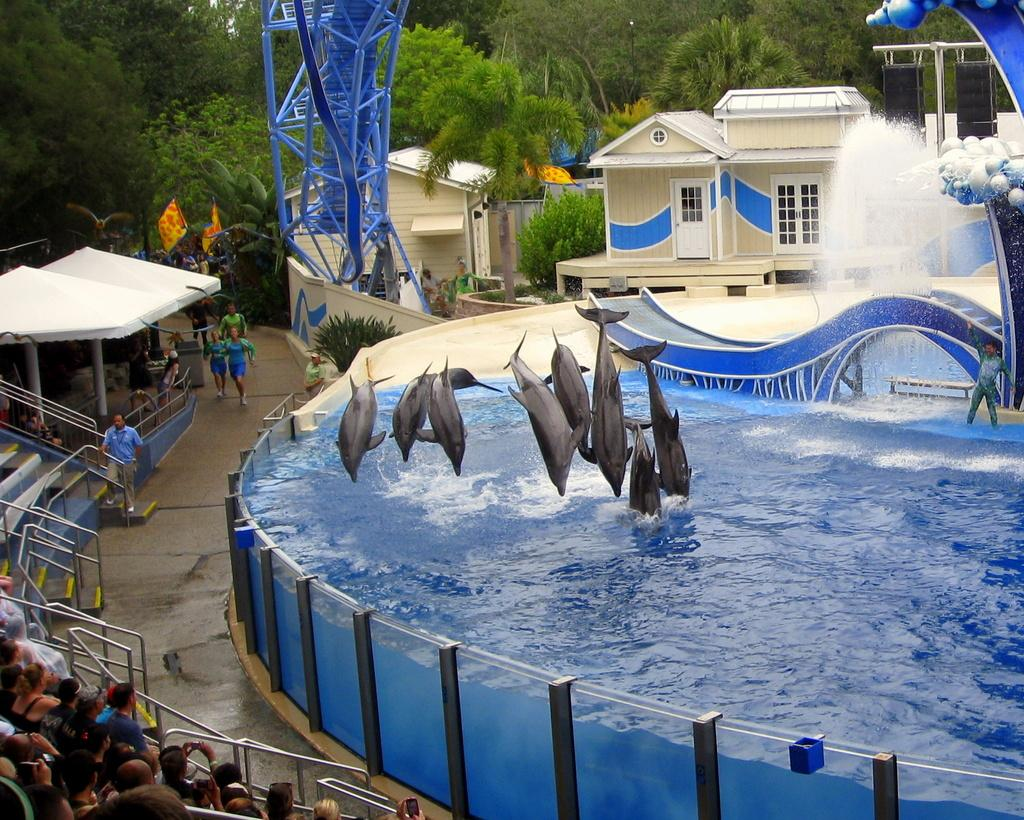What animals are performing an action in the image? There are dolphins jumping into the water in the image. Who else is present in the image besides the dolphins? There is a group of people in the image. What architectural feature can be seen in the image? There are stairs in the image. What type of structures are visible in the image? There are buildings in the image. What natural elements are present in the image? There are trees in the image. Can you describe any other objects in the image? There are some other objects in the image, but their specific details are not mentioned in the provided facts. What type of boot is being used for decision-making in the image? There is no boot or decision-making process present in the image. What mode of transport is visible in the image? There is no mode of transport visible in the image. 